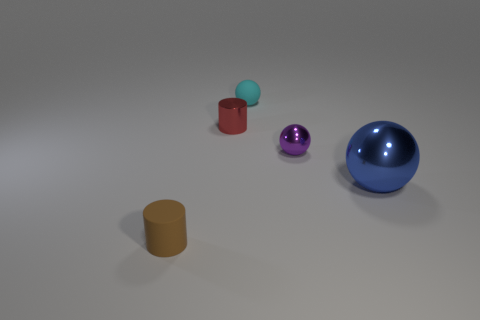What number of objects are large shiny spheres or cyan metallic blocks?
Offer a very short reply. 1. There is a matte thing behind the tiny red thing; is its size the same as the rubber object on the left side of the tiny cyan thing?
Your answer should be compact. Yes. Are there any tiny cyan metallic things of the same shape as the tiny purple object?
Offer a very short reply. No. Are there fewer purple metallic balls that are in front of the small metallic ball than red metal cylinders?
Offer a very short reply. Yes. Is the tiny cyan object the same shape as the small purple object?
Make the answer very short. Yes. There is a metallic object that is left of the cyan rubber sphere; how big is it?
Keep it short and to the point. Small. There is a brown thing that is made of the same material as the small cyan thing; what size is it?
Provide a succinct answer. Small. Is the number of big brown objects less than the number of cylinders?
Keep it short and to the point. Yes. There is a red cylinder that is the same size as the purple shiny sphere; what is it made of?
Make the answer very short. Metal. Is the number of cylinders greater than the number of objects?
Make the answer very short. No. 